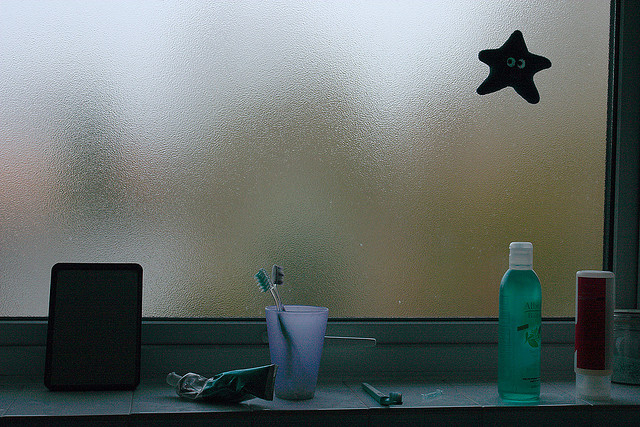Can you describe the main features of this image for me? The image captures a dimly lit window sill, adorned with a variety of everyday objects that hint at domestic life. The primary elements include three toothbrushes nestled inside a semi-transparent cup, suggesting shared usage, possibly by a family or roommates. Adjacent to these, lying horizontally, is a green tube perhaps of toothpaste which complements the aqua-colored bottle of Aloe Vera lotion standing tall next to a stout, red cylindrical container; these might be skincare or grooming products. A whimsical touch is added by a starfish-shaped decoration clinging to the frosted glass window, slightly off to the right. The scene is softly illuminated by the diffused light filtering through the glass, creating a serene yet lived-in atmosphere. The entire setup is reflected in a dark, rectangular mirror lying face-up on the sill, quietly observing the still life before it. 